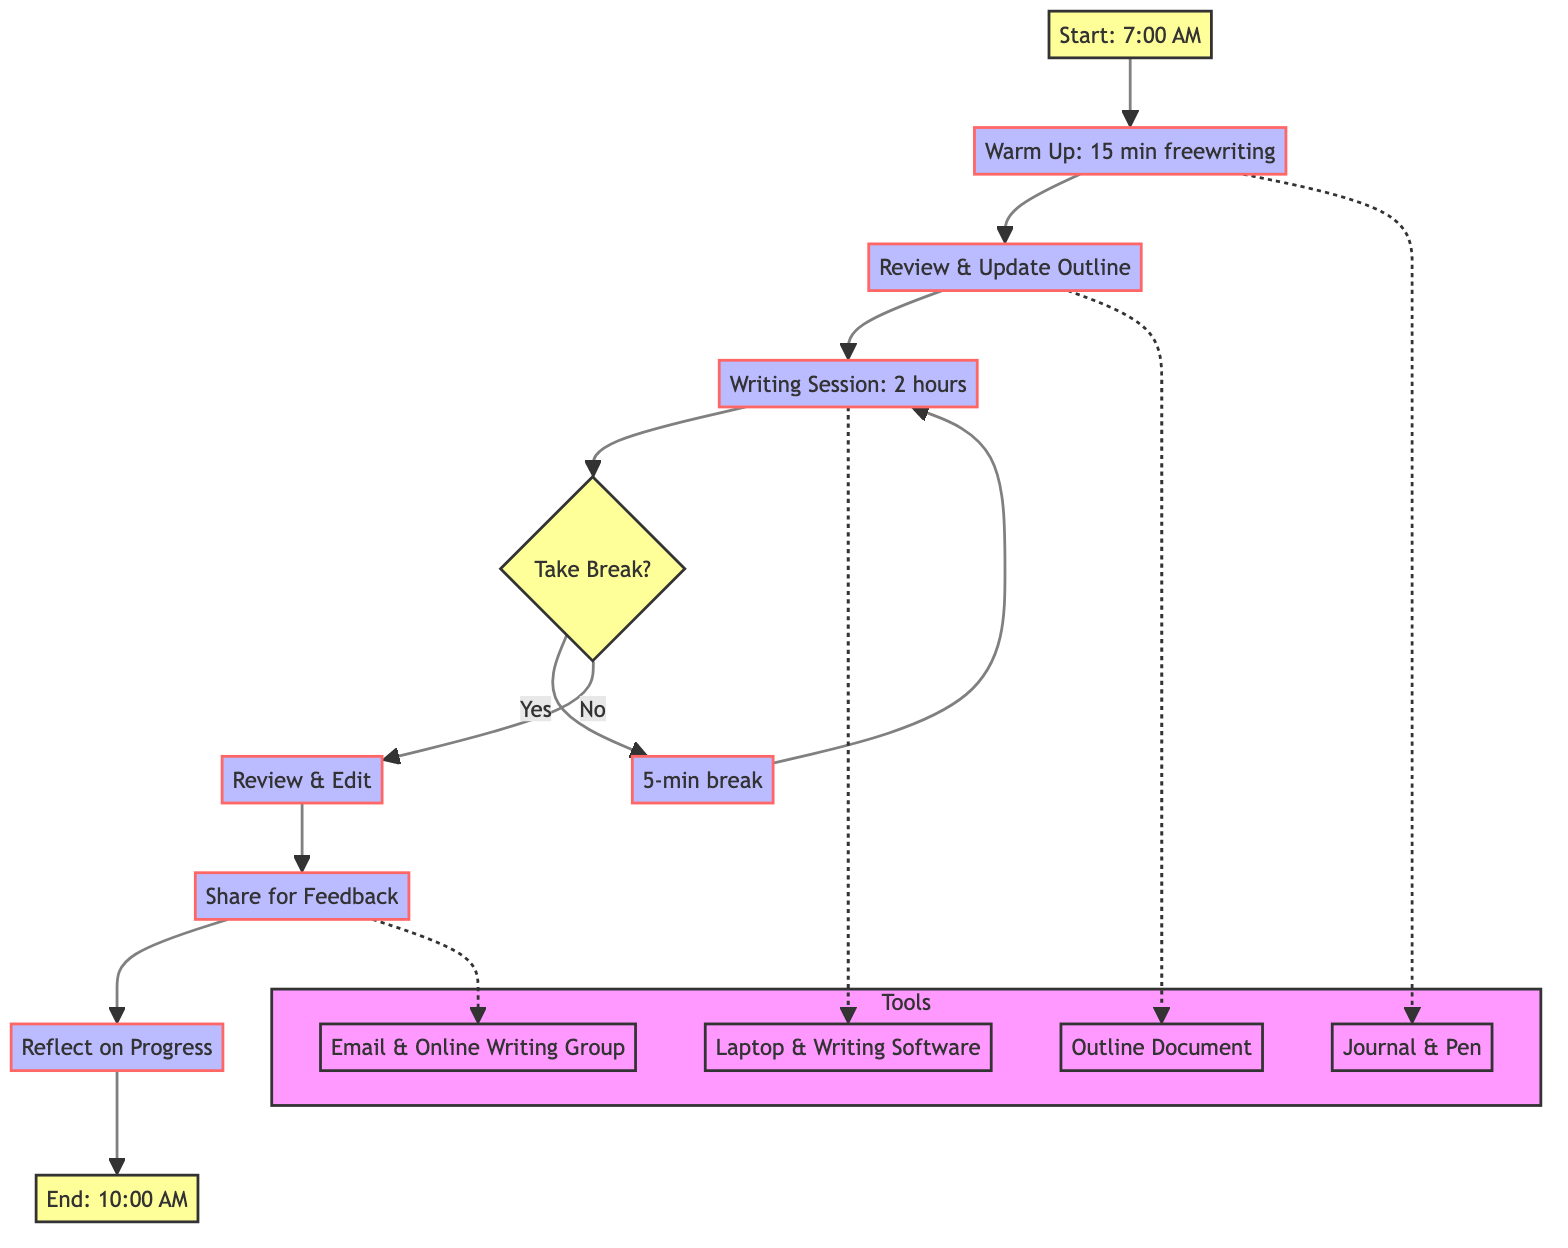What is the start time for the daily writing routine? The diagram specifies the start time at node A, which states "7:00 AM."
Answer: 7:00 AM What activity follows the warm-up session? After the warm-up session at node B, the next activity is reviewing and updating the outline at node C.
Answer: Review & Update Outline How long is the writing session? According to node D, the writing session lasts for "2 hours."
Answer: 2 hours What happens after the writing session if breaks are taken? If breaks are taken, as shown by the decision node E, the flow goes to node F for a "5-min break" before returning to node D for another writing session.
Answer: 5-min break What tools are used during the warm-up? The diagram indicates the tools for warming up at node K and specifically lists "Journal & Pen."
Answer: Journal & Pen How many total activities are there in the daily writing routine? By counting the distinct actions or nodes in the flowchart, there are six main activities (Warm Up, Outline, Writing Session, Review & Edit, Share for Feedback, Reflect on Progress).
Answer: 6 What occurs at the end of the writing routine? The last action in the flowchart is indicated at node J, which involves ending the session at "10:00 AM."
Answer: 10:00 AM What technique is recommended for taking breaks? The flowchart mentions using the "Pomodoro Technique" at node E to guide break-taking.
Answer: Pomodoro Technique What type of feedback is received after sharing the work? The feedback described at node H is characterized as "constructive feedback" from trusted peers or mentors.
Answer: Constructive feedback 